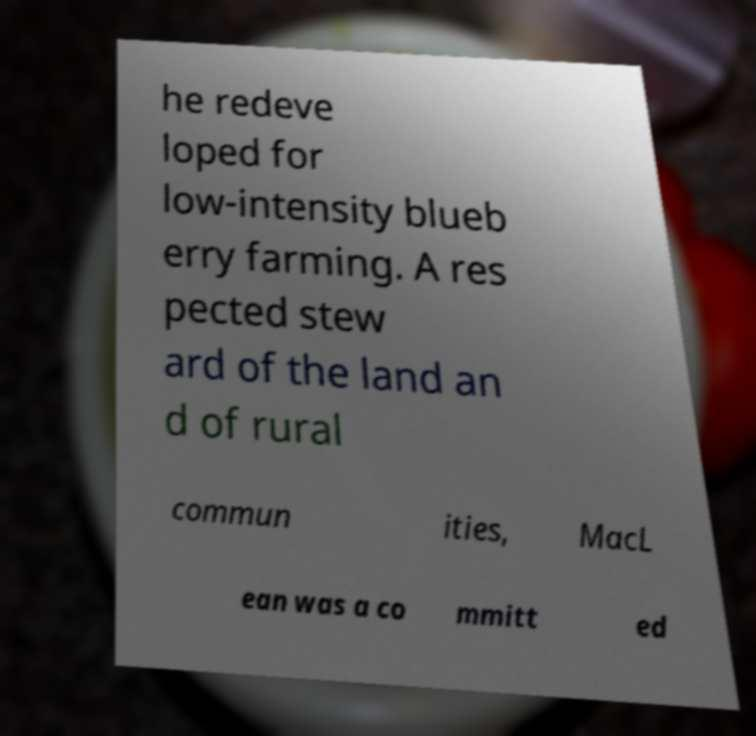Could you extract and type out the text from this image? he redeve loped for low-intensity blueb erry farming. A res pected stew ard of the land an d of rural commun ities, MacL ean was a co mmitt ed 